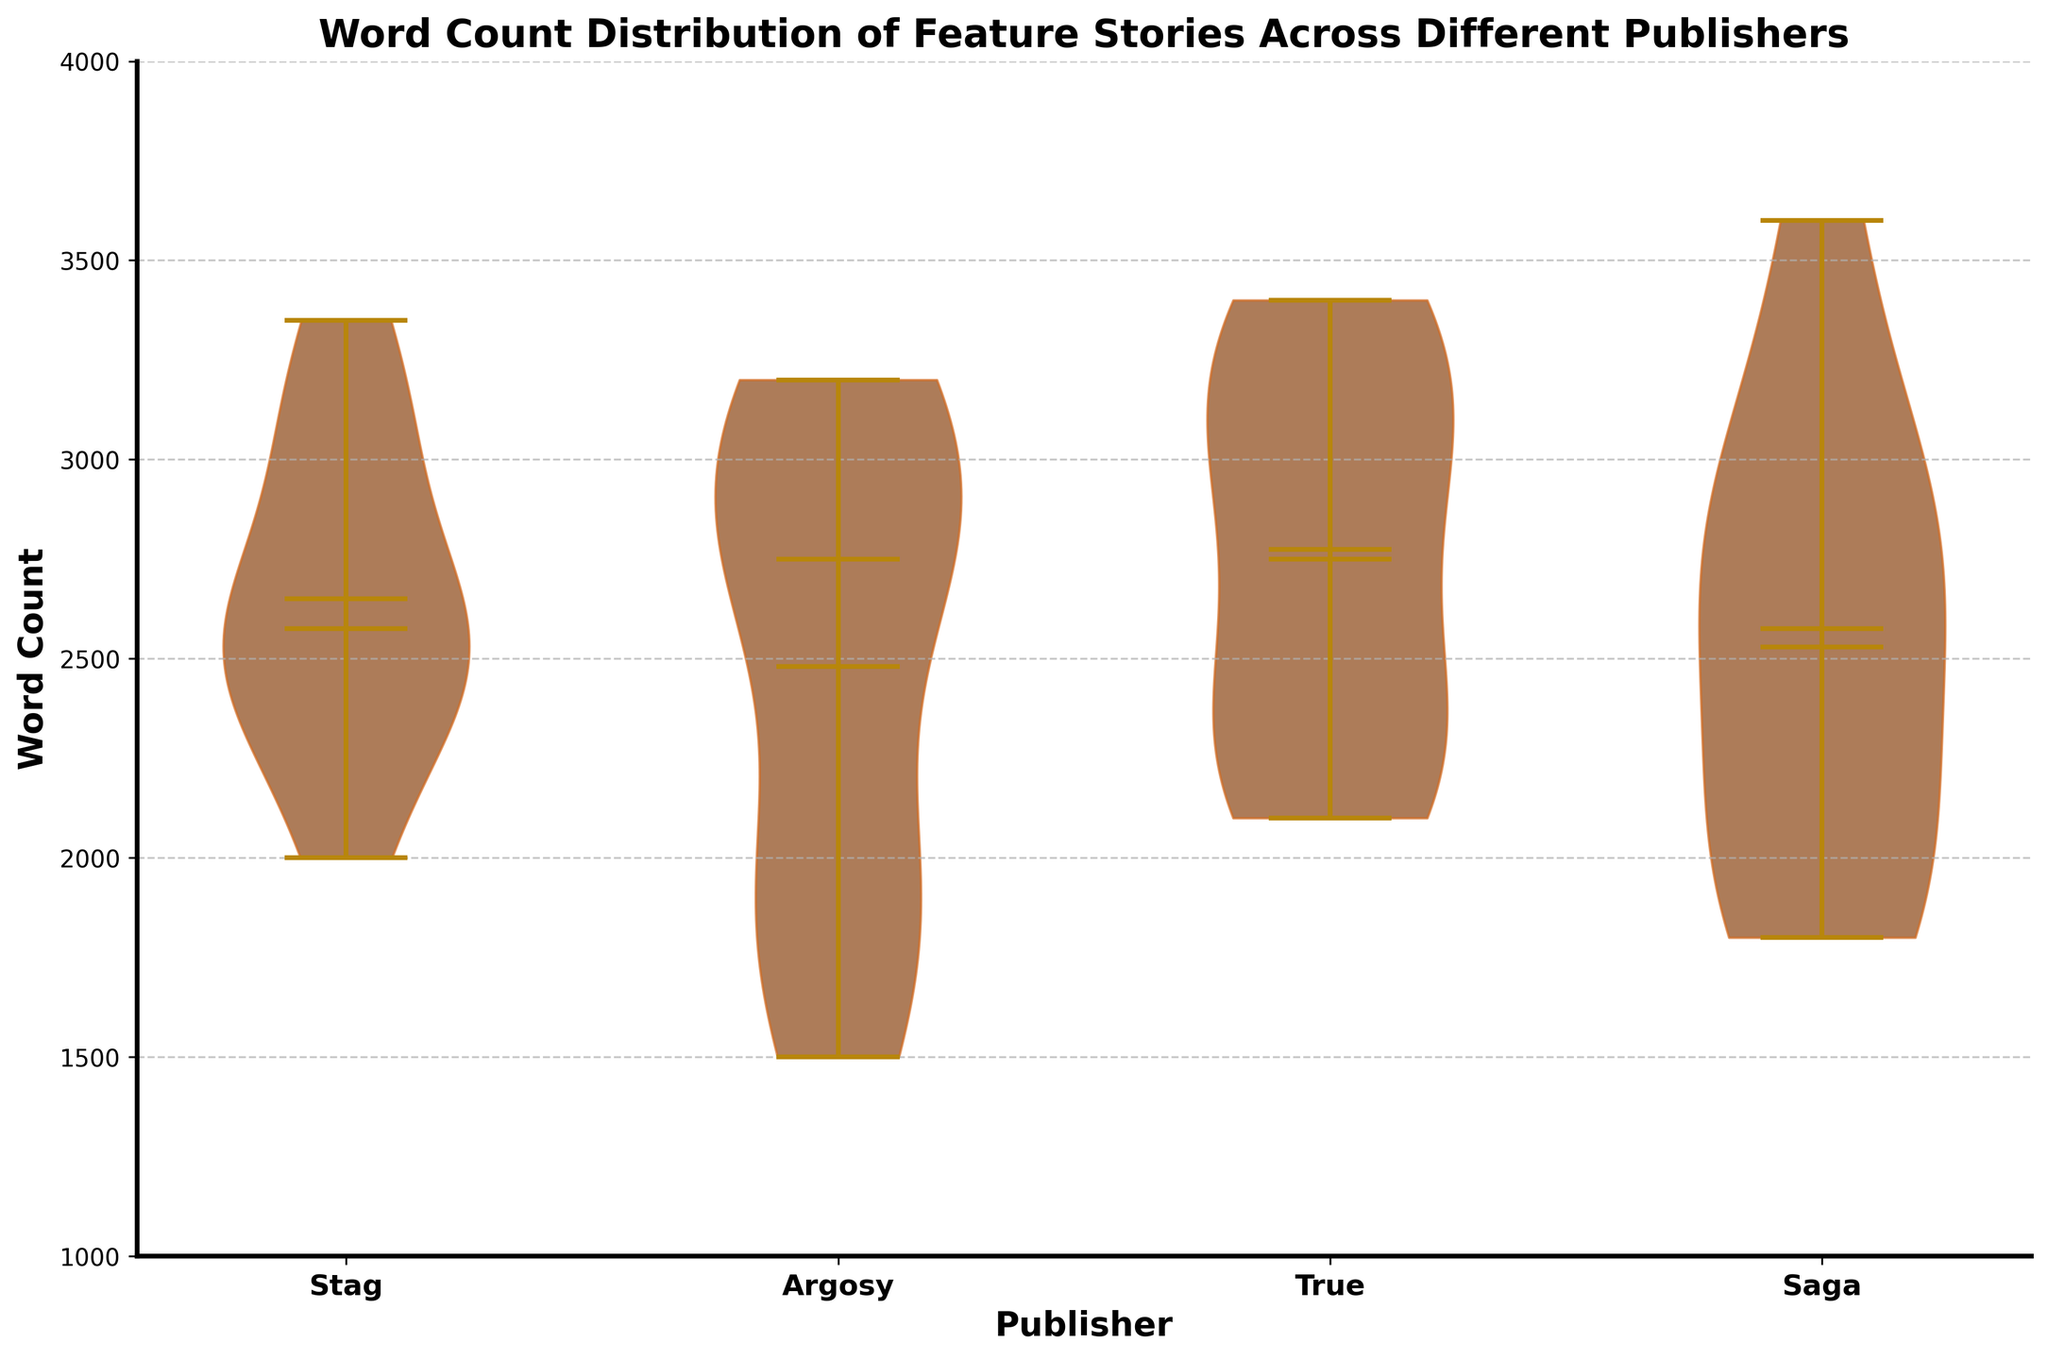What is the title of the plot? The title of the plot is displayed at the top of the figure in bold text, specifying what the figure is about.
Answer: Word Count Distribution of Feature Stories Across Different Publishers Which publisher has the widest distribution of word counts? The width of the violin plot for each publisher indicates the distribution. The broader the violin, the wider the distribution.
Answer: True What is the median word count for stories published by Saga? The figure marks the median values with a horizontal line in the middle of each violin plot.
Answer: 2500 Which publisher's stories have the highest mean word count? The mean is indicated by a dot in the middle and center of each violin plot.
Answer: Stag What is the range of word counts for stories published by Argosy? The range is indicated by the vertical span of the violin plot, from the bottom to the top marker.
Answer: 1500 to 3200 How do the median word counts for True and Argosy compare? Compare the position of the horizontal lines in the violin plots for True and Argosy. True's median is slightly higher.
Answer: True's median is higher Which publisher has the smallest overall range of word counts? The publisher with the smallest vertical span (shortest height) in their respective violin plot.
Answer: Saga How does the variability of word counts compare between Stag and Saga? Look at the width of the violins for Stag and Saga; a wider violin means more variability.
Answer: Stag has more variability What is the approximate mean word count for stories from True? The mean is represented by the dot on the True violin plot.
Answer: Approximately 2800 Compare the upper extreme word count of Saga to that of Stag. The upper extreme is indicated by the highest point on each violin plot. Compare the top of the Saga and Stag violins.
Answer: Saga's is higher 